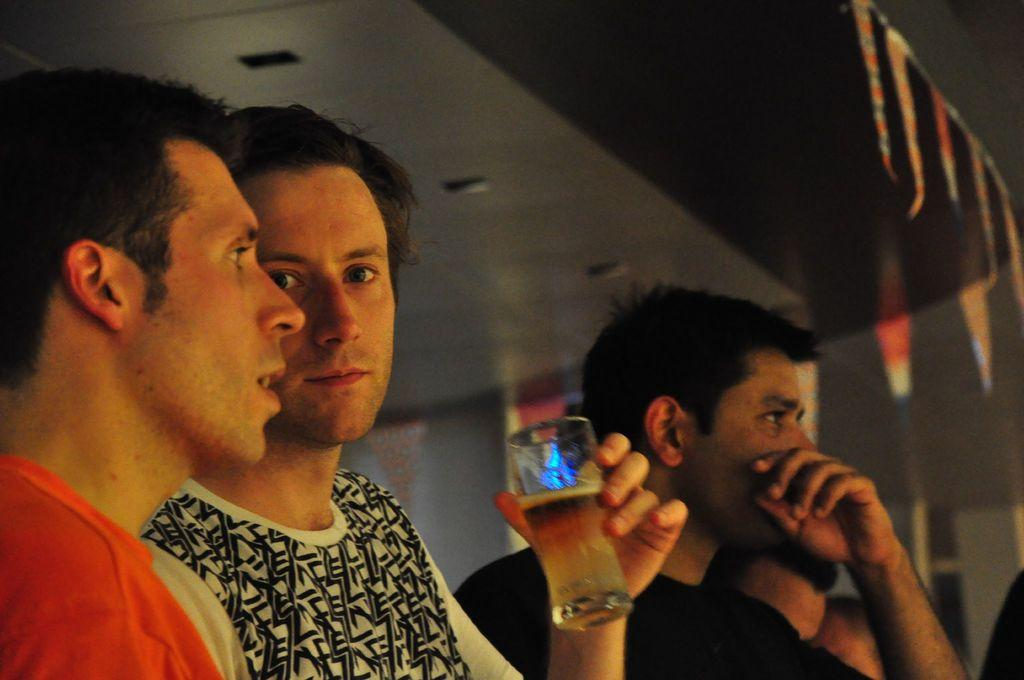How many people are in the image? There are persons in the image, but the exact number is not specified. What is the man holding in the image? The man is holding a glass with some liquid in it. What type of decorations can be seen in the image? There are decorative flags in the image. Where is the scene taking place? The scene is taking place on a rooftop. What type of legal advice is the lawyer providing to the band in the image? There is no lawyer or band present in the image, so it is not possible to answer that question. 